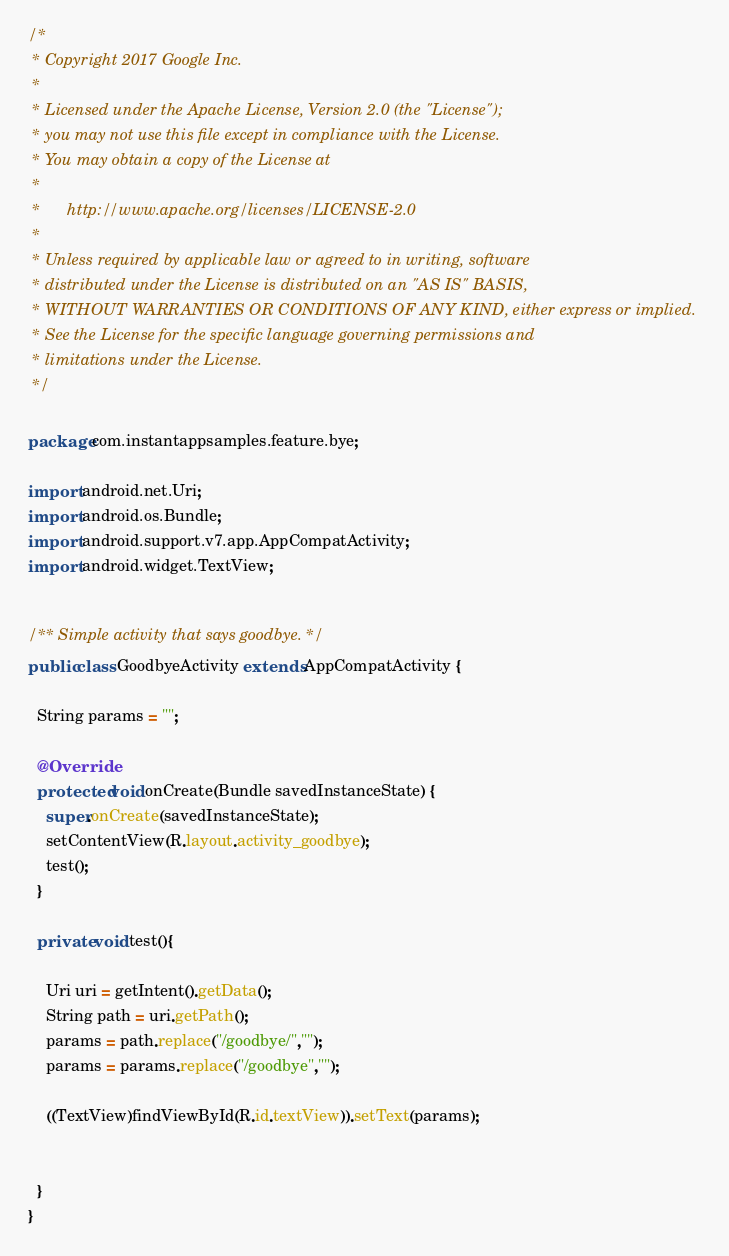<code> <loc_0><loc_0><loc_500><loc_500><_Java_>/*
 * Copyright 2017 Google Inc.
 *
 * Licensed under the Apache License, Version 2.0 (the "License");
 * you may not use this file except in compliance with the License.
 * You may obtain a copy of the License at
 *
 *      http://www.apache.org/licenses/LICENSE-2.0
 *
 * Unless required by applicable law or agreed to in writing, software
 * distributed under the License is distributed on an "AS IS" BASIS,
 * WITHOUT WARRANTIES OR CONDITIONS OF ANY KIND, either express or implied.
 * See the License for the specific language governing permissions and
 * limitations under the License.
 */

package com.instantappsamples.feature.bye;

import android.net.Uri;
import android.os.Bundle;
import android.support.v7.app.AppCompatActivity;
import android.widget.TextView;


/** Simple activity that says goodbye. */
public class GoodbyeActivity extends AppCompatActivity {

  String params = "";

  @Override
  protected void onCreate(Bundle savedInstanceState) {
    super.onCreate(savedInstanceState);
    setContentView(R.layout.activity_goodbye);
    test();
  }

  private void test(){

    Uri uri = getIntent().getData();
    String path = uri.getPath();
    params = path.replace("/goodbye/","");
    params = params.replace("/goodbye","");

    ((TextView)findViewById(R.id.textView)).setText(params);


  }
}
</code> 